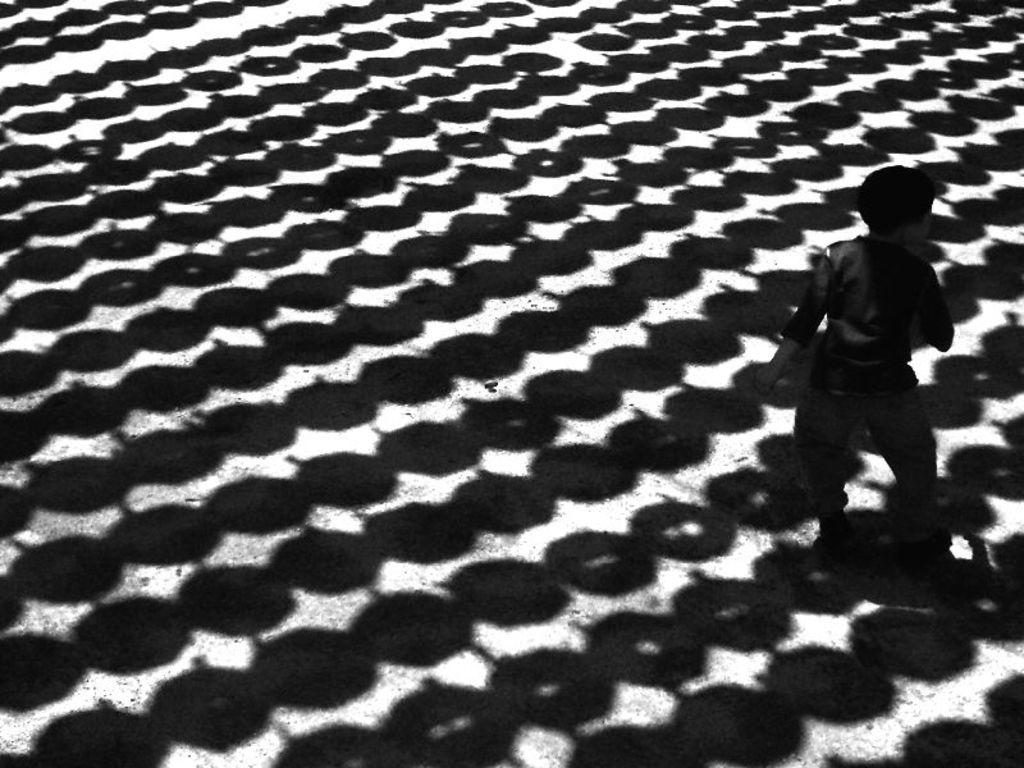What is the position of the person in the image? There is a person standing on the right side of the image. What else can be observed in the image besides the person? There are shadows of some objects visible in the image. What type of winter clothing is the person wearing in the image? There is no indication of winter clothing or any specific weather conditions in the image, as it only shows a person standing on the right side and shadows of some objects. 